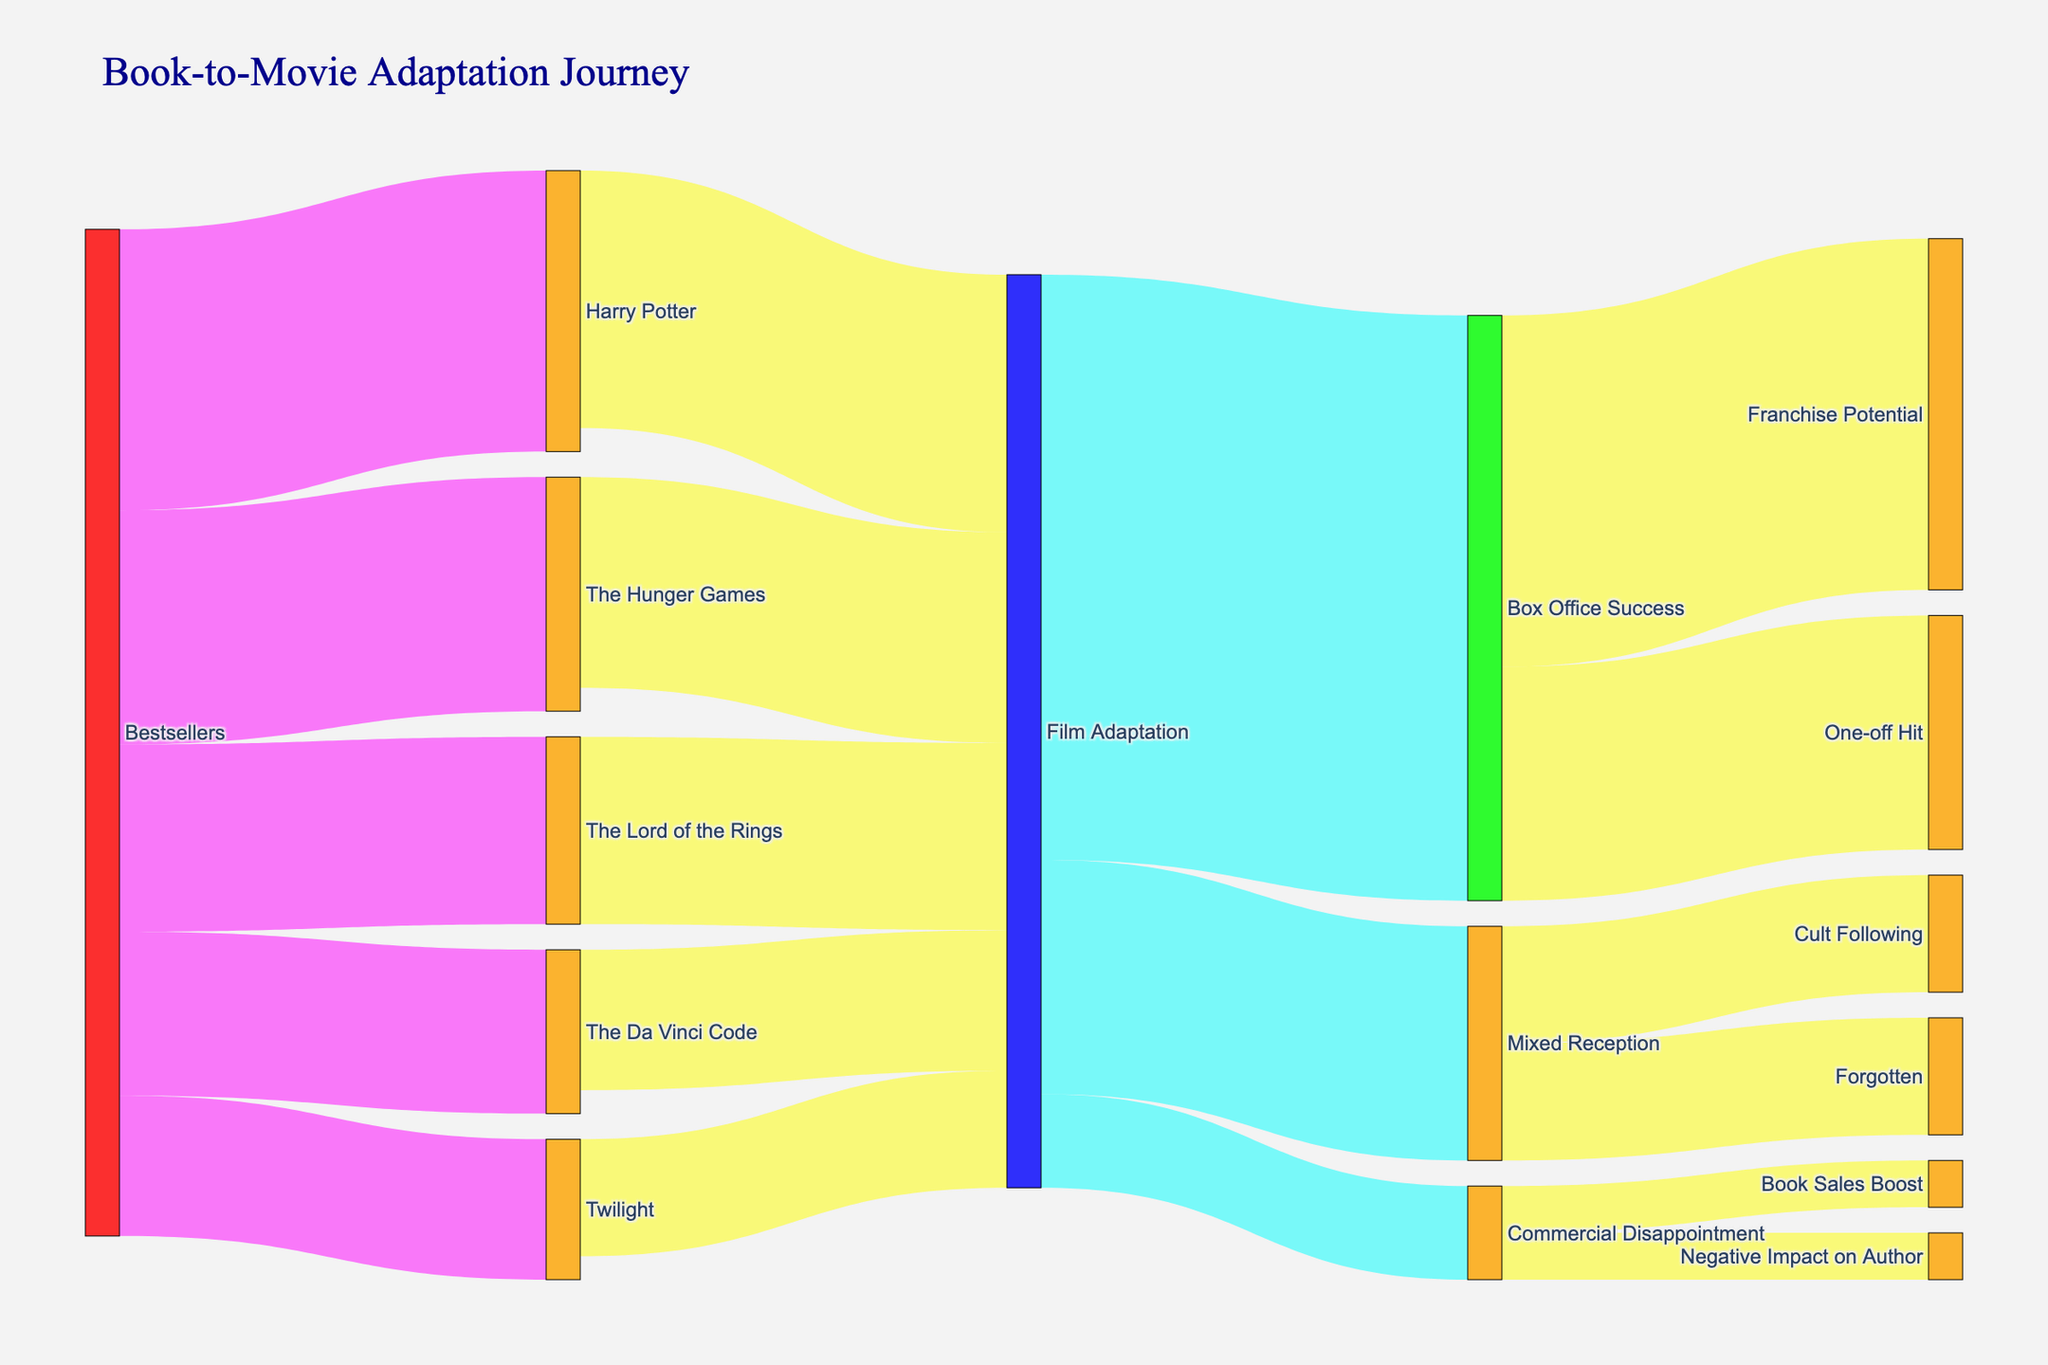What is the title of the Sankey Diagram? The title of a Sankey Diagram is usually displayed prominently at the top of the figure. For this particular diagram, it is "Book-to-Movie Adaptation Journey".
Answer: Book-to-Movie Adaptation Journey How many bestsellers are depicted in the diagram? The source nodes connected directly to "Bestsellers" are "The Hunger Games", "Harry Potter", "The Lord of the Rings", "The Da Vinci Code", and "Twilight". Counting these connections gives the total number of bestsellers.
Answer: 5 Which film adaptation has the highest value? To find this, look at the values linked directly from the "Bestsellers" to specific books. "Harry Potter" has the highest value of 12.
Answer: Harry Potter How many film adaptations had mixed receptions? Look at the connections labeled "Film Adaptation" and see which of them lead to "Mixed Reception". There are 10 film adaptations that received a mixed reception.
Answer: 10 Which categories follow 'Box Office Success'? After identifying the node "Box Office Success", look for the target nodes connected to it. They are "Franchise Potential" and "One-off Hit".
Answer: Franchise Potential and One-off Hit What is the combined value of adaptations from "Bestsellers" to "Film Adaptation"? Sum all values that flow from "Bestsellers" directly to "Film Adaptation": 10 + 12 + 8 + 7 + 6 = 43.
Answer: 43 Which book had the least successful film adaptation in terms of Box Office Success? Look at the values from each book adaptation to "Film Adaptation" and beyond to "Box Office Success". "Twilight" has the smallest value transitioning from "Bestsellers" at 6, and subsequently a lower "Film Adaptation" value at 5, indicating less comparative success.
Answer: Twilight What is the total number of outcomes possible from 'Film Adaptation'? Evaluate all the distinct nodes receiving links from "Film Adaptation". These are "Box Office Success", "Mixed Reception", and "Commercial Disappointment", making the total outcomes 3.
Answer: 3 Are there more films with "Box Office Success" or "Mixed Reception"? Check the values of links from "Film Adaptation" to "Box Office Success" and "Mixed Reception". "Box Office Success" has a total value of 25 while "Mixed Reception" has 10.
Answer: Box Office Success 